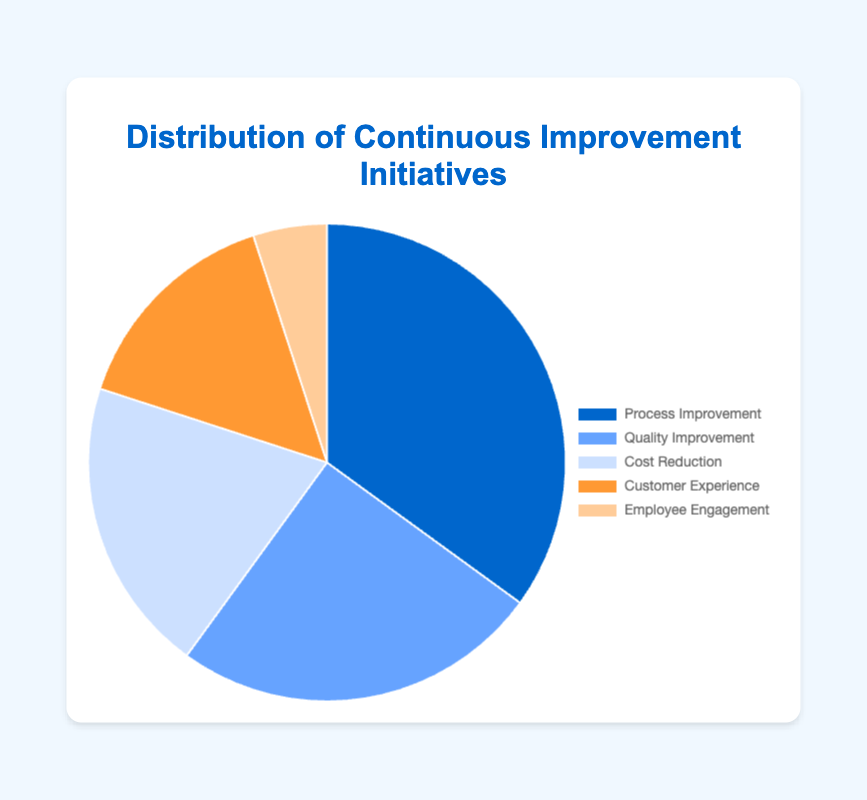Which initiative has the largest share in the distribution? The figure shows a pie chart where the size of each slice represents the percentage of each initiative. The largest slice is for Process Improvement.
Answer: Process Improvement Which two initiatives together account for more than half of the total initiatives? By looking at the figure, you can see that Process Improvement is 35% and Quality Improvement is 25%. Adding these percentages gives 60%, which is more than half.
Answer: Process Improvement and Quality Improvement How much more prevalent is Process Improvement compared to Cost Reduction? The figure shows that Process Improvement is 35% and Cost Reduction is 20%. Subtracting these gives 15%.
Answer: 15% What is the visual color used for Customer Experience? The pie chart uses a specific color for each initiative. Customer Experience is represented in orange.
Answer: Orange Which initiative has the smallest share in the distribution, and what percentage does it represent? By observing the size of the slices, the smallest slice corresponds to Employee Engagement, representing 5%.
Answer: Employee Engagement, 5% How many initiatives individually account for a fifth or more of the total initiatives? A fifth of 100% is 20%. In the figure, Process Improvement (35%) and Quality Improvement (25%) both account for more than a fifth.
Answer: Two initiatives If we combine the percentages of Customer Experience and Employee Engagement, what percentage would they represent? Customer Experience is 15% and Employee Engagement is 5%. Adding these two percentages gives 20%.
Answer: 20% Which initiatives together make up exactly 50% of the initiatives? Cost Reduction (20%) and Customer Experience (15%) together account for 35%, and adding Employee Engagement (5%) totals exactly 50%.
Answer: Cost Reduction, Customer Experience, and Employee Engagement What percentage of the initiatives is dedicated to cost-related improvements, considering both Cost Reduction and Process Improvement? The figure shows Cost Reduction is 20% and Process Improvement is 35%. Adding these gives 55%.
Answer: 55% 